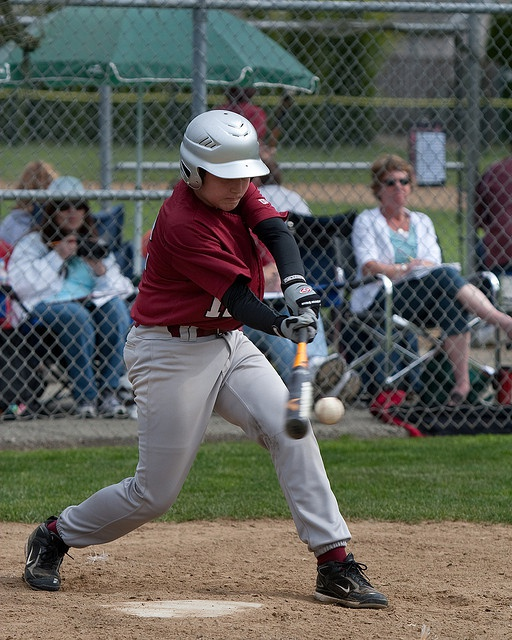Describe the objects in this image and their specific colors. I can see people in black, gray, darkgray, and maroon tones, umbrella in black and teal tones, people in black, gray, lavender, and darkgray tones, people in black, gray, blue, and darkgray tones, and chair in black, gray, and darkblue tones in this image. 